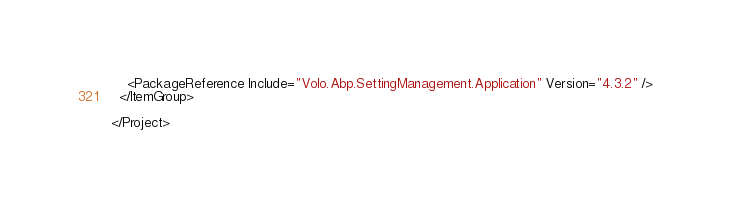Convert code to text. <code><loc_0><loc_0><loc_500><loc_500><_XML_>    <PackageReference Include="Volo.Abp.SettingManagement.Application" Version="4.3.2" />
  </ItemGroup>

</Project>
</code> 